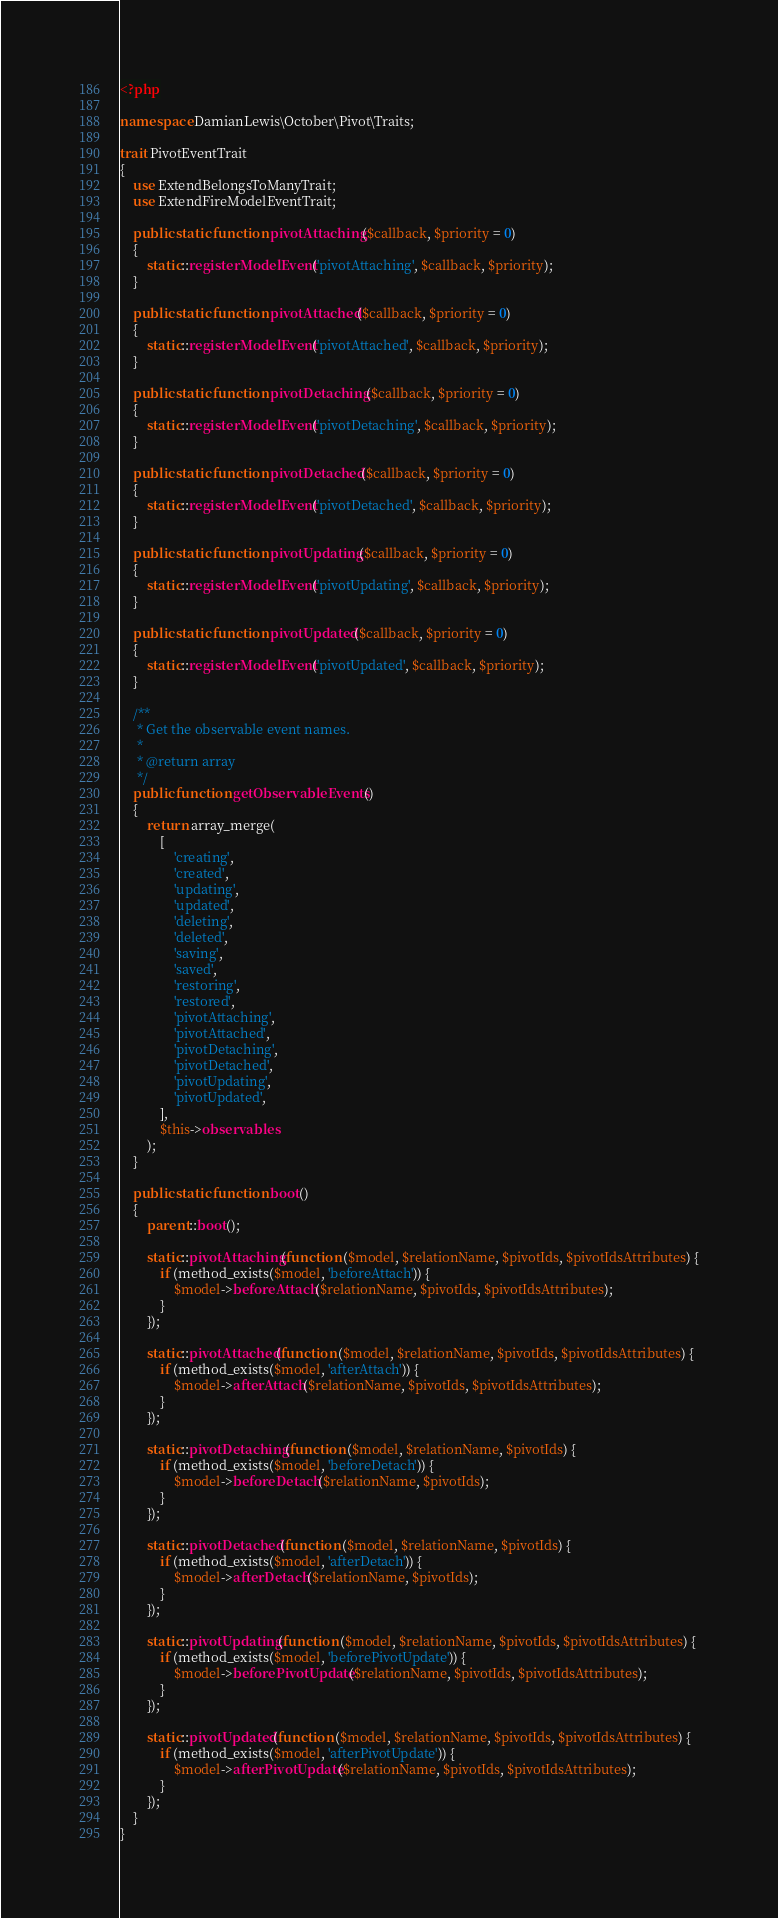<code> <loc_0><loc_0><loc_500><loc_500><_PHP_><?php

namespace DamianLewis\October\Pivot\Traits;

trait PivotEventTrait
{
    use ExtendBelongsToManyTrait;
    use ExtendFireModelEventTrait;

    public static function pivotAttaching($callback, $priority = 0)
    {
        static::registerModelEvent('pivotAttaching', $callback, $priority);
    }

    public static function pivotAttached($callback, $priority = 0)
    {
        static::registerModelEvent('pivotAttached', $callback, $priority);
    }

    public static function pivotDetaching($callback, $priority = 0)
    {
        static::registerModelEvent('pivotDetaching', $callback, $priority);
    }

    public static function pivotDetached($callback, $priority = 0)
    {
        static::registerModelEvent('pivotDetached', $callback, $priority);
    }

    public static function pivotUpdating($callback, $priority = 0)
    {
        static::registerModelEvent('pivotUpdating', $callback, $priority);
    }

    public static function pivotUpdated($callback, $priority = 0)
    {
        static::registerModelEvent('pivotUpdated', $callback, $priority);
    }

    /**
     * Get the observable event names.
     *
     * @return array
     */
    public function getObservableEvents()
    {
        return array_merge(
            [
                'creating',
                'created',
                'updating',
                'updated',
                'deleting',
                'deleted',
                'saving',
                'saved',
                'restoring',
                'restored',
                'pivotAttaching',
                'pivotAttached',
                'pivotDetaching',
                'pivotDetached',
                'pivotUpdating',
                'pivotUpdated',
            ],
            $this->observables
        );
    }
    
    public static function boot()
    {
        parent::boot();

        static::pivotAttaching(function ($model, $relationName, $pivotIds, $pivotIdsAttributes) {
            if (method_exists($model, 'beforeAttach')) {
                $model->beforeAttach($relationName, $pivotIds, $pivotIdsAttributes);
            }
        });

        static::pivotAttached(function ($model, $relationName, $pivotIds, $pivotIdsAttributes) {
            if (method_exists($model, 'afterAttach')) {
                $model->afterAttach($relationName, $pivotIds, $pivotIdsAttributes);
            }
        });

        static::pivotDetaching(function ($model, $relationName, $pivotIds) {
            if (method_exists($model, 'beforeDetach')) {
                $model->beforeDetach($relationName, $pivotIds);
            }
        });

        static::pivotDetached(function ($model, $relationName, $pivotIds) {
            if (method_exists($model, 'afterDetach')) {
                $model->afterDetach($relationName, $pivotIds);
            }
        });

        static::pivotUpdating(function ($model, $relationName, $pivotIds, $pivotIdsAttributes) {
            if (method_exists($model, 'beforePivotUpdate')) {
                $model->beforePivotUpdate($relationName, $pivotIds, $pivotIdsAttributes);
            }
        });

        static::pivotUpdated(function ($model, $relationName, $pivotIds, $pivotIdsAttributes) {
            if (method_exists($model, 'afterPivotUpdate')) {
                $model->afterPivotUpdate($relationName, $pivotIds, $pivotIdsAttributes);
            }
        });
    }
}
</code> 